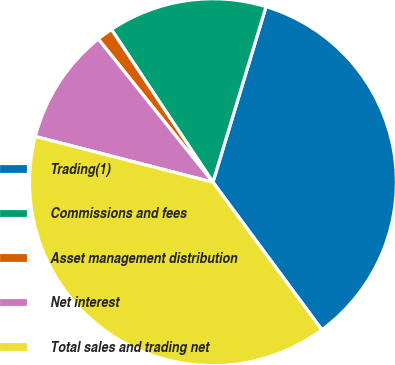<chart> <loc_0><loc_0><loc_500><loc_500><pie_chart><fcel>Trading(1)<fcel>Commissions and fees<fcel>Asset management distribution<fcel>Net interest<fcel>Total sales and trading net<nl><fcel>35.2%<fcel>14.01%<fcel>1.41%<fcel>10.24%<fcel>39.13%<nl></chart> 